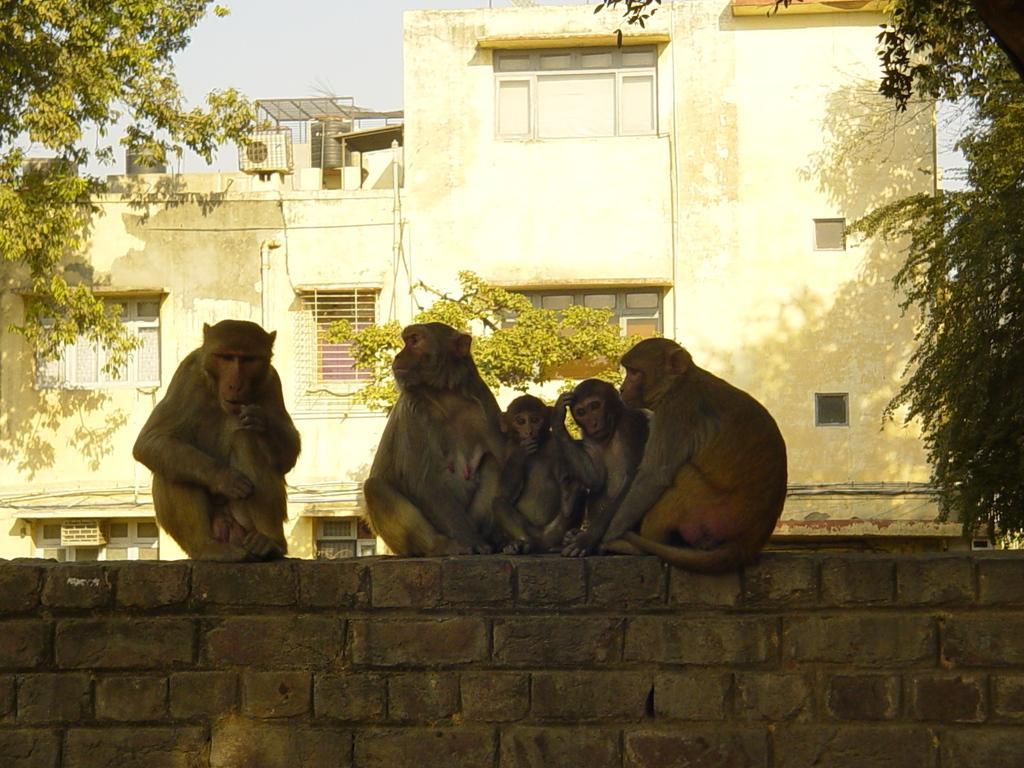Please provide a concise description of this image. In this image we can see a group of monkeys sitting on the wall. In the background there are buildings, trees, overhead tanks, air conditioners and sky. 